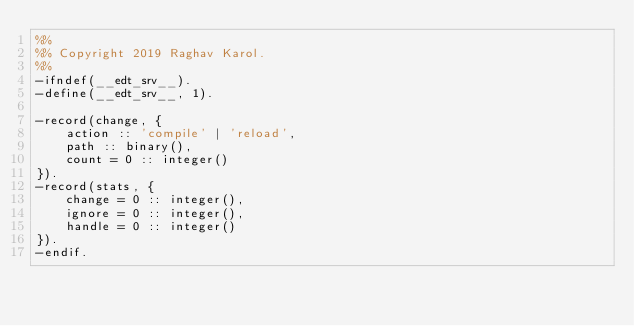<code> <loc_0><loc_0><loc_500><loc_500><_Erlang_>%%
%% Copyright 2019 Raghav Karol.
%%
-ifndef(__edt_srv__).
-define(__edt_srv__, 1).

-record(change, {
    action :: 'compile' | 'reload',
    path :: binary(),
    count = 0 :: integer()
}).
-record(stats, {
    change = 0 :: integer(),
    ignore = 0 :: integer(),
    handle = 0 :: integer()
}).
-endif.
</code> 